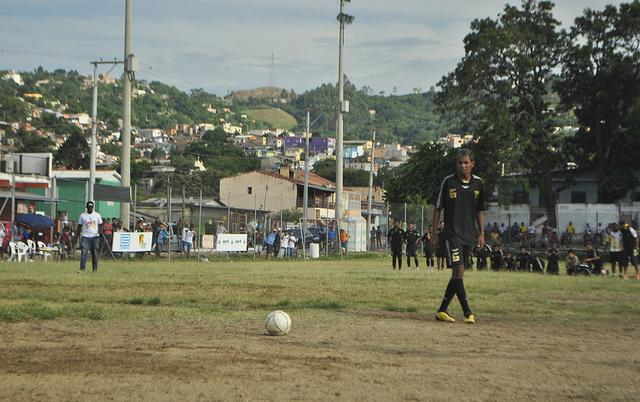What international tournament takes place every 4 years where this sport is played? Please explain your reasoning. world cup. Every four years the nations of the world gather to compete in this soccer tournament. 